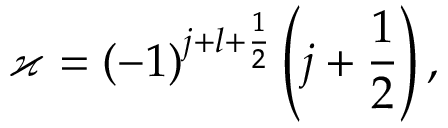<formula> <loc_0><loc_0><loc_500><loc_500>\varkappa = ( - 1 ) ^ { j + l + \frac { 1 } { 2 } } \left ( j + \frac { 1 } { 2 } \right ) ,</formula> 